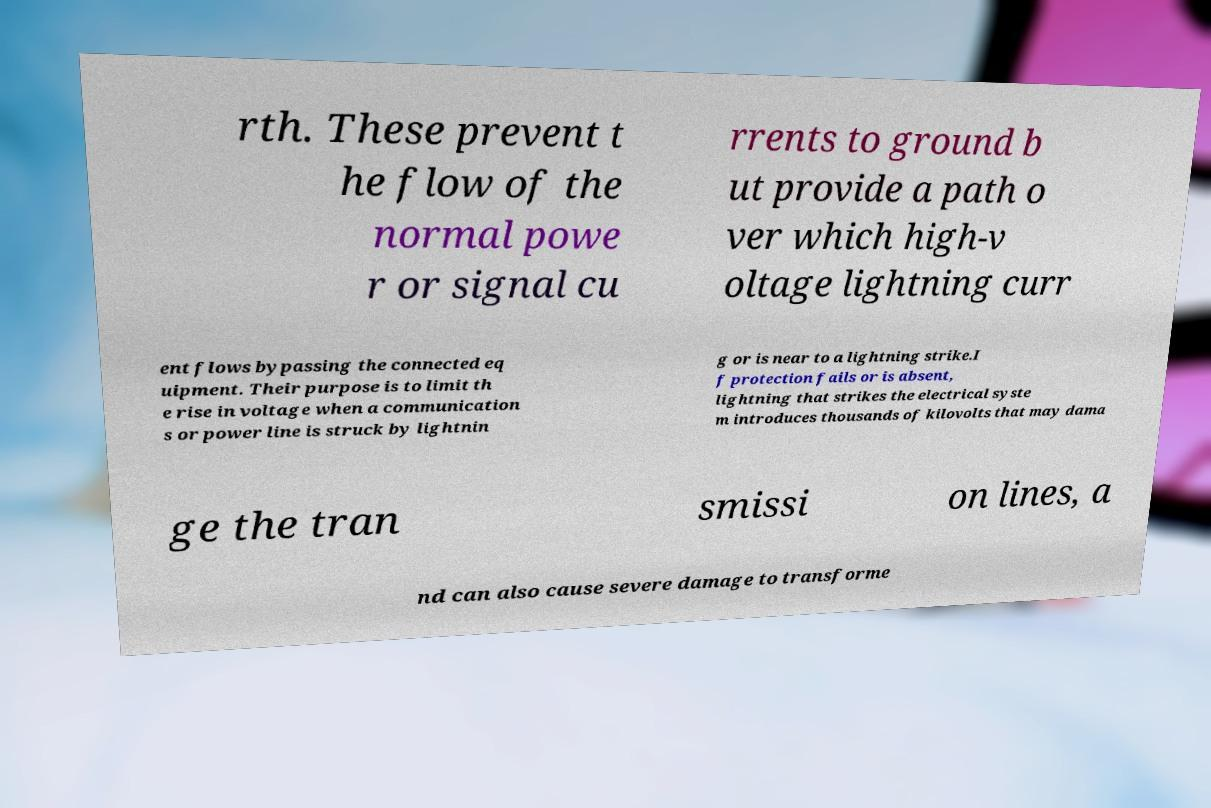Please read and relay the text visible in this image. What does it say? rth. These prevent t he flow of the normal powe r or signal cu rrents to ground b ut provide a path o ver which high-v oltage lightning curr ent flows bypassing the connected eq uipment. Their purpose is to limit th e rise in voltage when a communication s or power line is struck by lightnin g or is near to a lightning strike.I f protection fails or is absent, lightning that strikes the electrical syste m introduces thousands of kilovolts that may dama ge the tran smissi on lines, a nd can also cause severe damage to transforme 